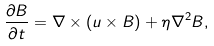Convert formula to latex. <formula><loc_0><loc_0><loc_500><loc_500>\frac { \partial B } { \partial t } = \nabla \times ( u \times B ) + \eta \nabla ^ { 2 } B , \\</formula> 